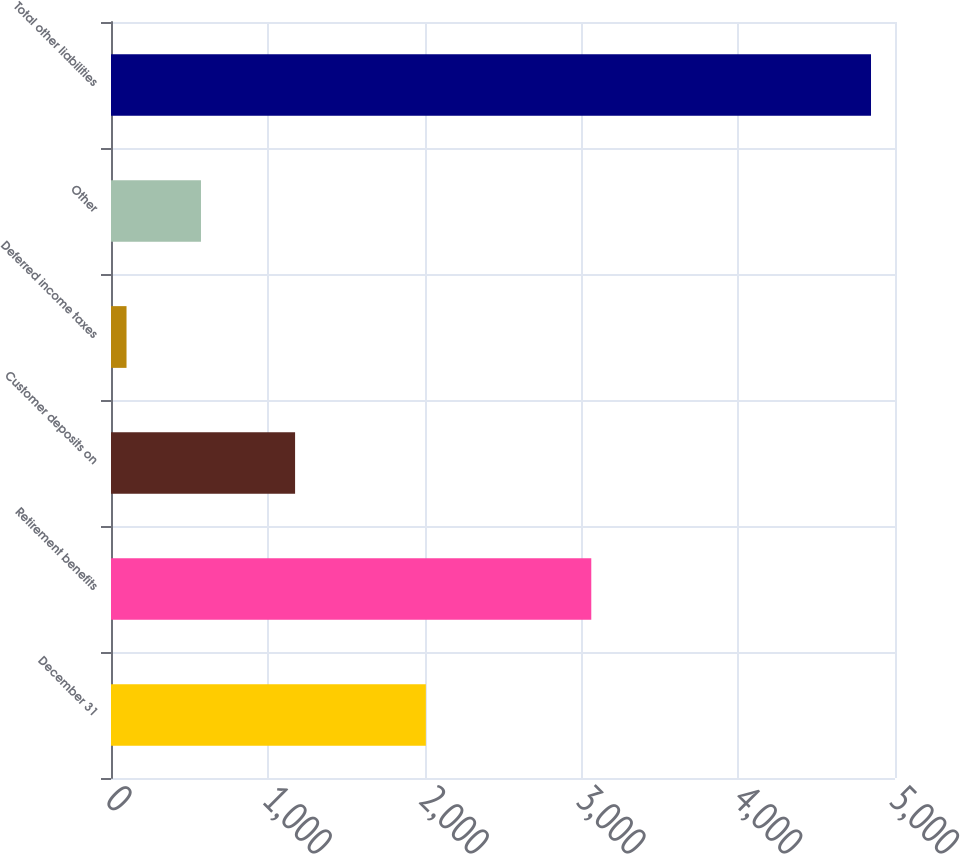Convert chart. <chart><loc_0><loc_0><loc_500><loc_500><bar_chart><fcel>December 31<fcel>Retirement benefits<fcel>Customer deposits on<fcel>Deferred income taxes<fcel>Other<fcel>Total other liabilities<nl><fcel>2008<fcel>3063<fcel>1174<fcel>99<fcel>573.8<fcel>4847<nl></chart> 